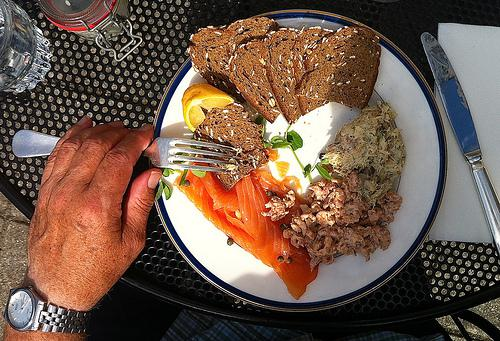Question: where was this picture taken?
Choices:
A. A hot dog stand.
B. A juice bar.
C. An ice cream truck.
D. An outside cafe.
Answer with the letter. Answer: D Question: what is the main color of the plate?
Choices:
A. Black.
B. Blue.
C. White.
D. Red.
Answer with the letter. Answer: C Question: what color is the table?
Choices:
A. Tan.
B. Grey.
C. Blue.
D. Black.
Answer with the letter. Answer: D 